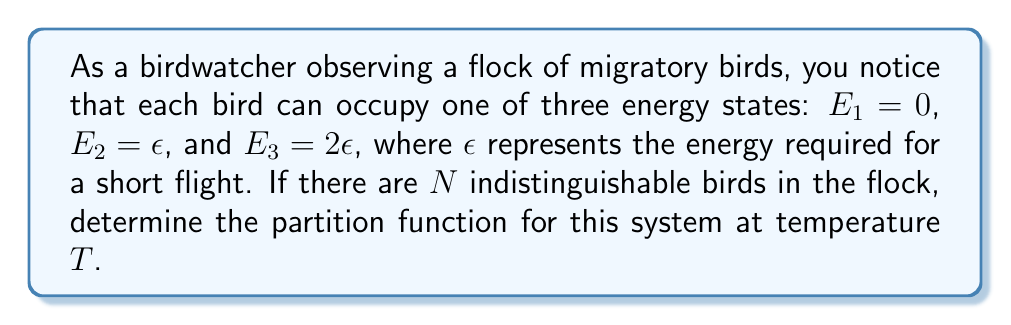What is the answer to this math problem? To solve this problem, we'll follow these steps:

1) The partition function $Z$ for a system of $N$ indistinguishable particles is given by:

   $$Z = \frac{1}{N!}(z^N)$$

   where $z$ is the single-particle partition function.

2) For a single bird, the partition function $z$ is the sum of the Boltzmann factors for each energy state:

   $$z = e^{-\beta E_1} + e^{-\beta E_2} + e^{-\beta E_3}$$

   where $\beta = \frac{1}{k_BT}$, $k_B$ is the Boltzmann constant, and $T$ is the temperature.

3) Substituting the energy values:

   $$z = e^{-\beta \cdot 0} + e^{-\beta \epsilon} + e^{-\beta \cdot 2\epsilon}$$

4) Simplify:

   $$z = 1 + e^{-\beta \epsilon} + e^{-2\beta \epsilon}$$

5) Now, we can write the partition function for the entire flock:

   $$Z = \frac{1}{N!}(1 + e^{-\beta \epsilon} + e^{-2\beta \epsilon})^N$$

This is the partition function for the system of $N$ indistinguishable migratory birds with the given energy states.
Answer: $$Z = \frac{1}{N!}(1 + e^{-\beta \epsilon} + e^{-2\beta \epsilon})^N$$ 